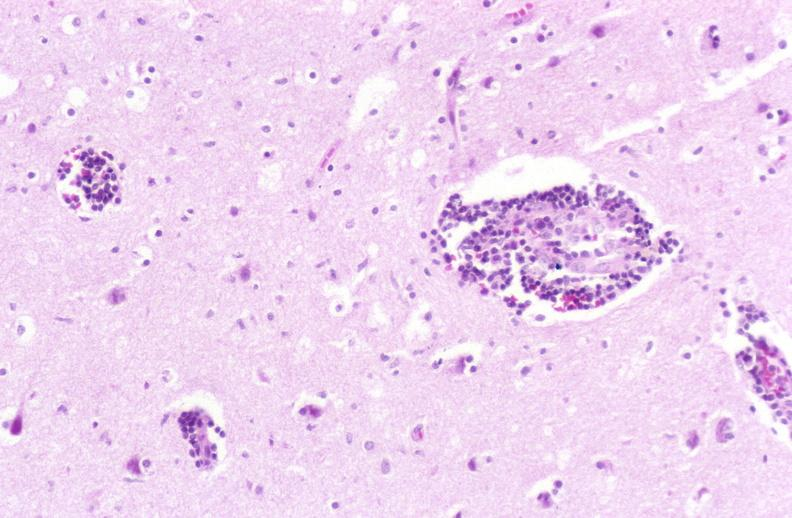s artery present?
Answer the question using a single word or phrase. No 